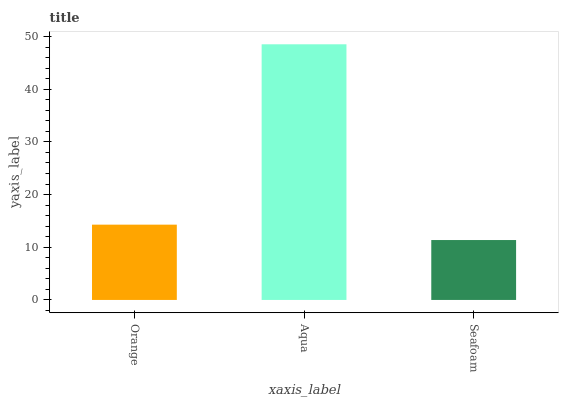Is Seafoam the minimum?
Answer yes or no. Yes. Is Aqua the maximum?
Answer yes or no. Yes. Is Aqua the minimum?
Answer yes or no. No. Is Seafoam the maximum?
Answer yes or no. No. Is Aqua greater than Seafoam?
Answer yes or no. Yes. Is Seafoam less than Aqua?
Answer yes or no. Yes. Is Seafoam greater than Aqua?
Answer yes or no. No. Is Aqua less than Seafoam?
Answer yes or no. No. Is Orange the high median?
Answer yes or no. Yes. Is Orange the low median?
Answer yes or no. Yes. Is Seafoam the high median?
Answer yes or no. No. Is Seafoam the low median?
Answer yes or no. No. 